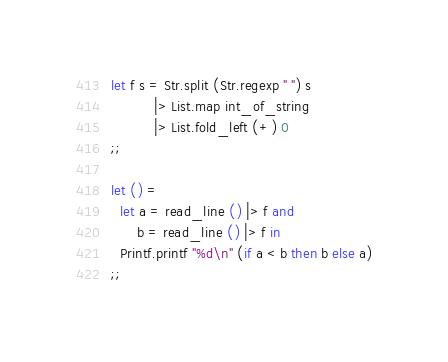Convert code to text. <code><loc_0><loc_0><loc_500><loc_500><_OCaml_>let f s = Str.split (Str.regexp " ") s
          |> List.map int_of_string
          |> List.fold_left (+) 0
;;

let () =
  let a = read_line () |> f and
      b = read_line () |> f in
  Printf.printf "%d\n" (if a < b then b else a)
;;</code> 